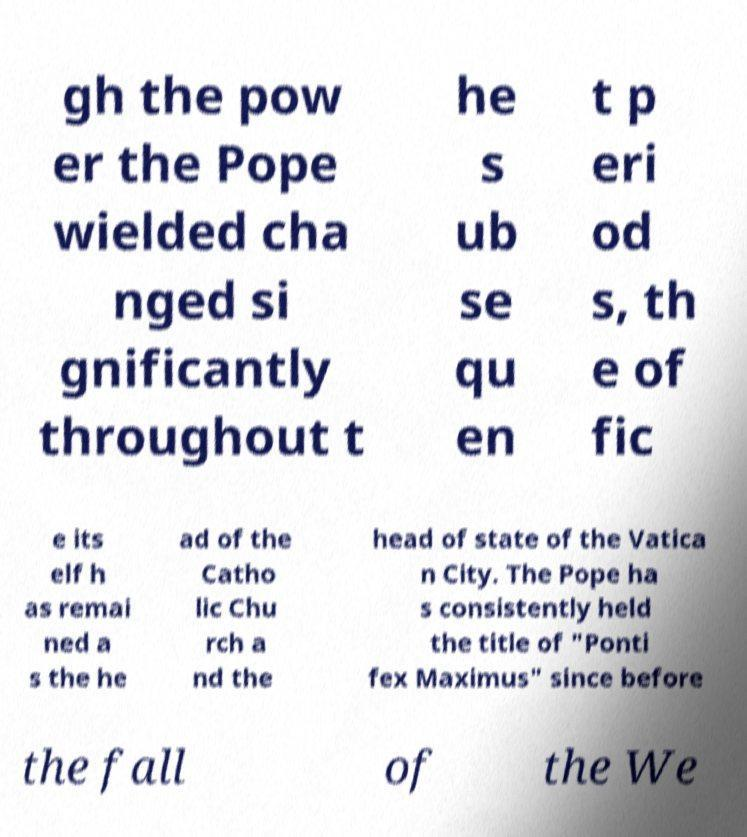Can you read and provide the text displayed in the image?This photo seems to have some interesting text. Can you extract and type it out for me? gh the pow er the Pope wielded cha nged si gnificantly throughout t he s ub se qu en t p eri od s, th e of fic e its elf h as remai ned a s the he ad of the Catho lic Chu rch a nd the head of state of the Vatica n City. The Pope ha s consistently held the title of "Ponti fex Maximus" since before the fall of the We 